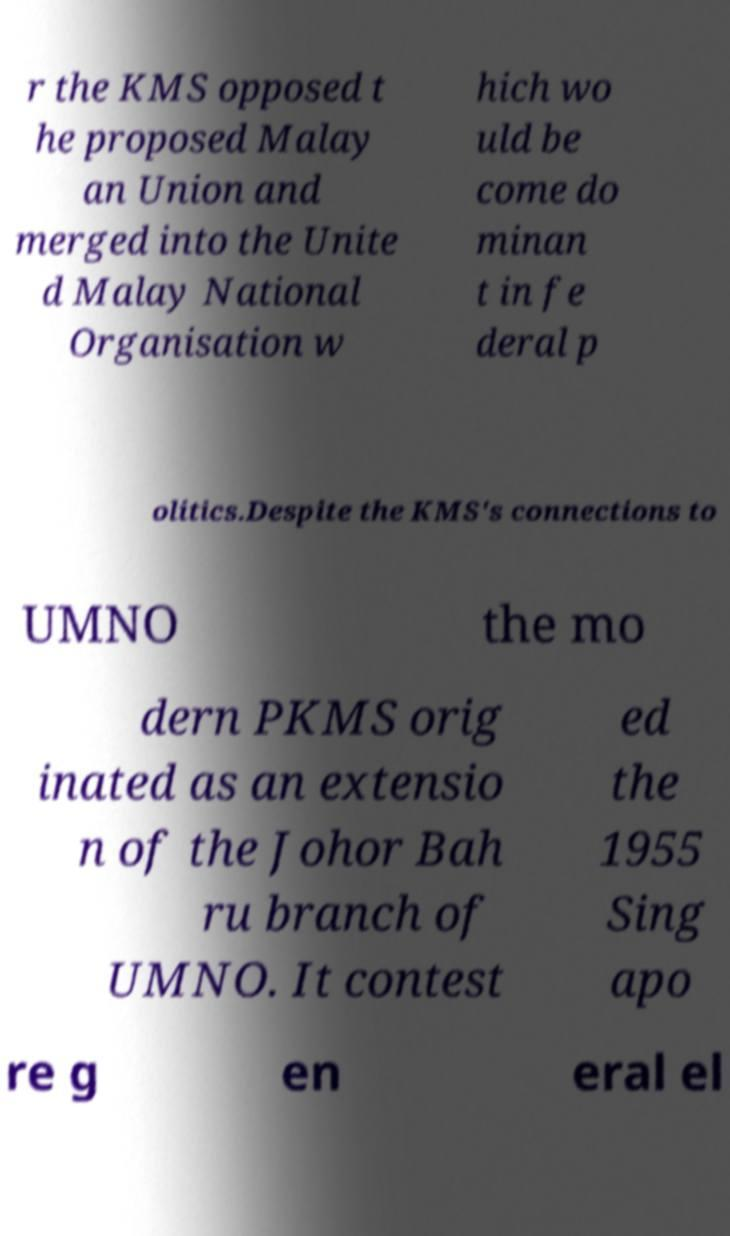Please read and relay the text visible in this image. What does it say? r the KMS opposed t he proposed Malay an Union and merged into the Unite d Malay National Organisation w hich wo uld be come do minan t in fe deral p olitics.Despite the KMS's connections to UMNO the mo dern PKMS orig inated as an extensio n of the Johor Bah ru branch of UMNO. It contest ed the 1955 Sing apo re g en eral el 